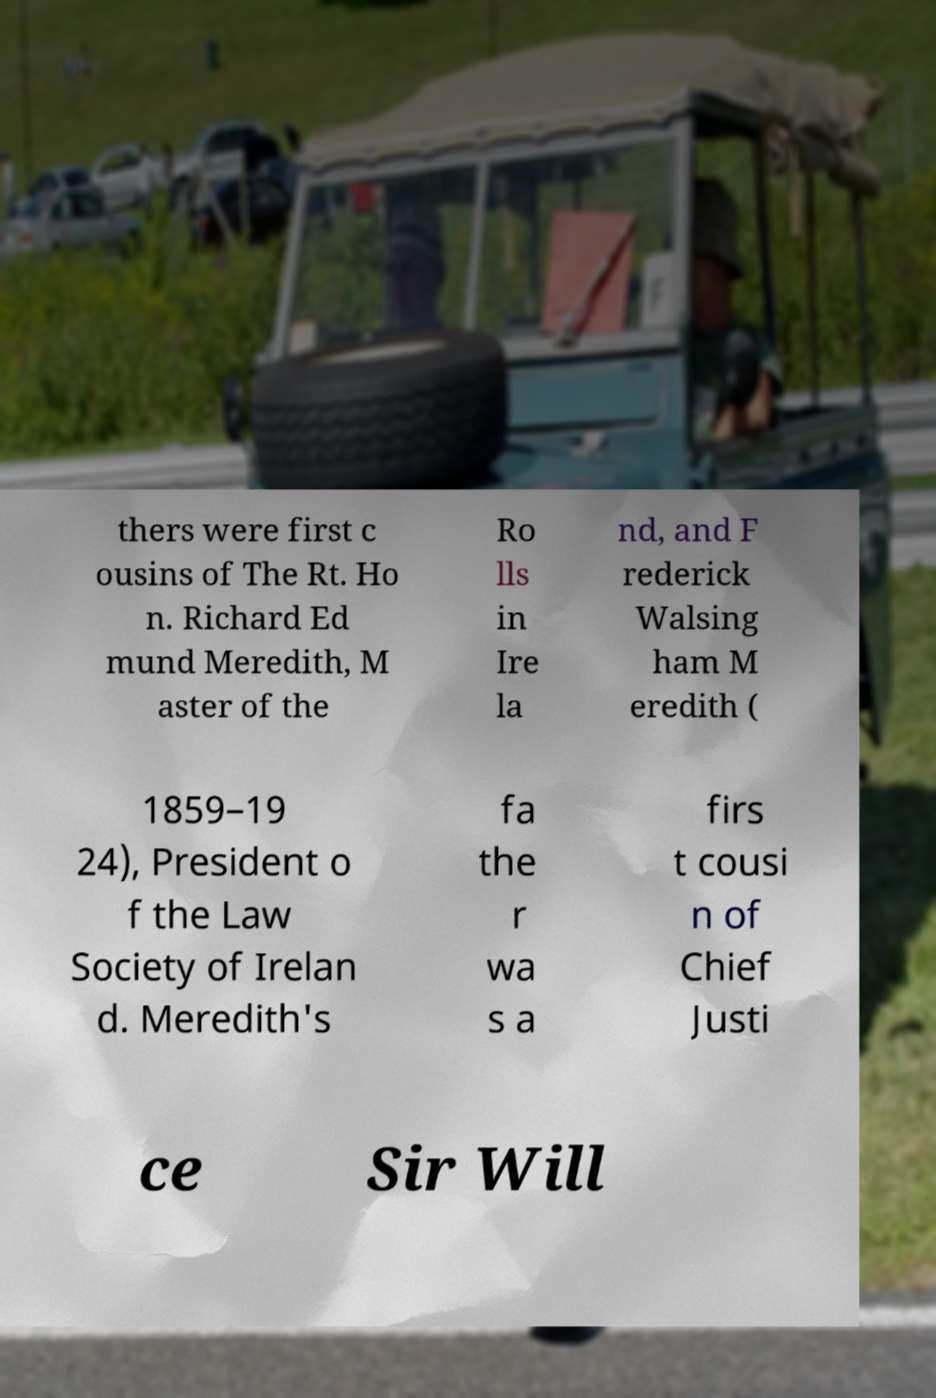I need the written content from this picture converted into text. Can you do that? thers were first c ousins of The Rt. Ho n. Richard Ed mund Meredith, M aster of the Ro lls in Ire la nd, and F rederick Walsing ham M eredith ( 1859–19 24), President o f the Law Society of Irelan d. Meredith's fa the r wa s a firs t cousi n of Chief Justi ce Sir Will 